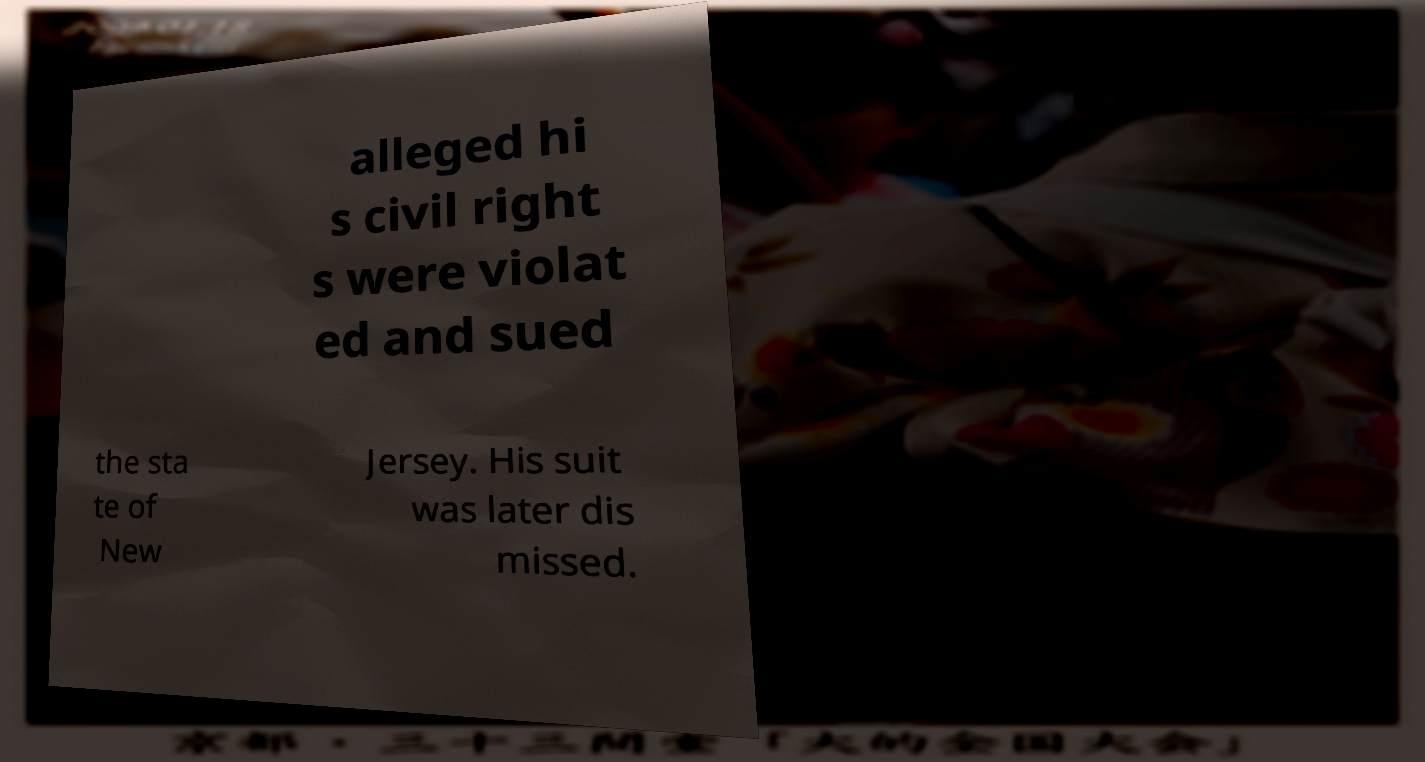Please identify and transcribe the text found in this image. alleged hi s civil right s were violat ed and sued the sta te of New Jersey. His suit was later dis missed. 